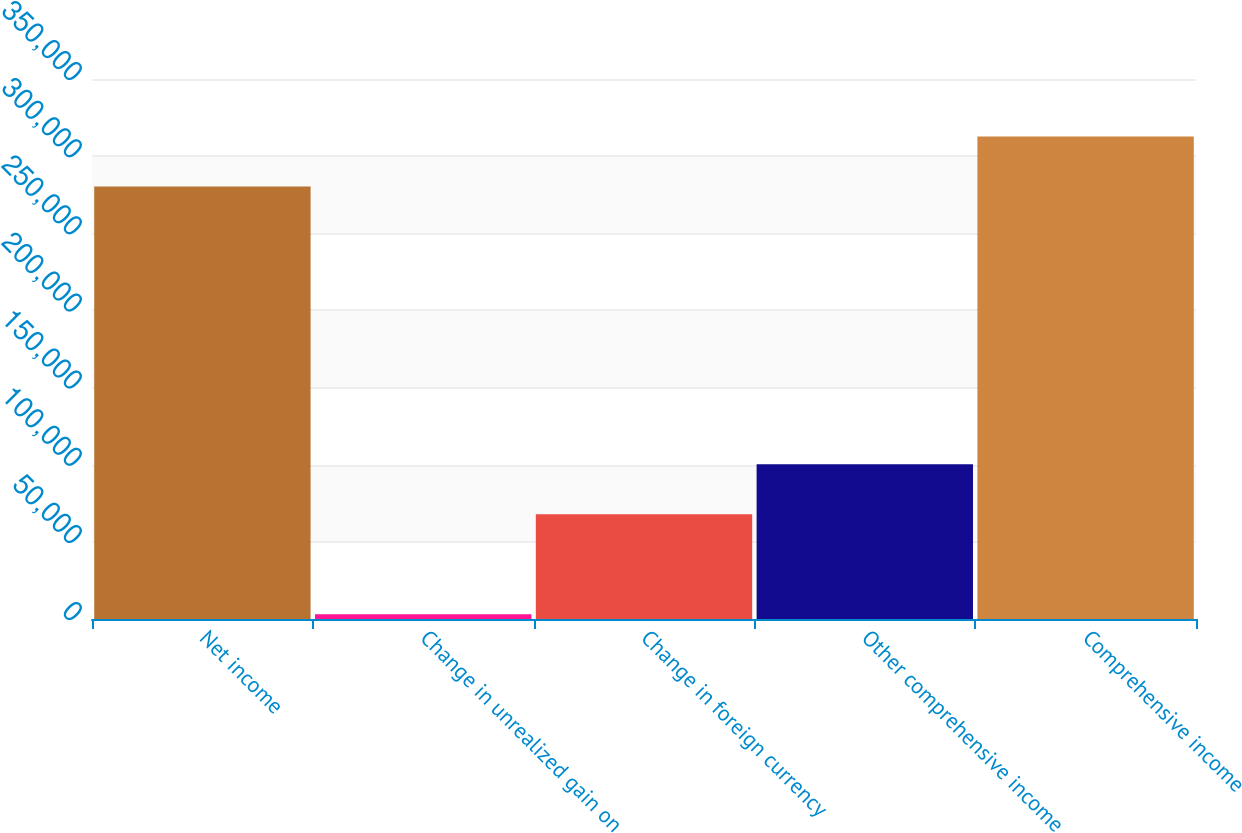<chart> <loc_0><loc_0><loc_500><loc_500><bar_chart><fcel>Net income<fcel>Change in unrealized gain on<fcel>Change in foreign currency<fcel>Other comprehensive income<fcel>Comprehensive income<nl><fcel>280275<fcel>3013<fcel>67861<fcel>100285<fcel>312699<nl></chart> 